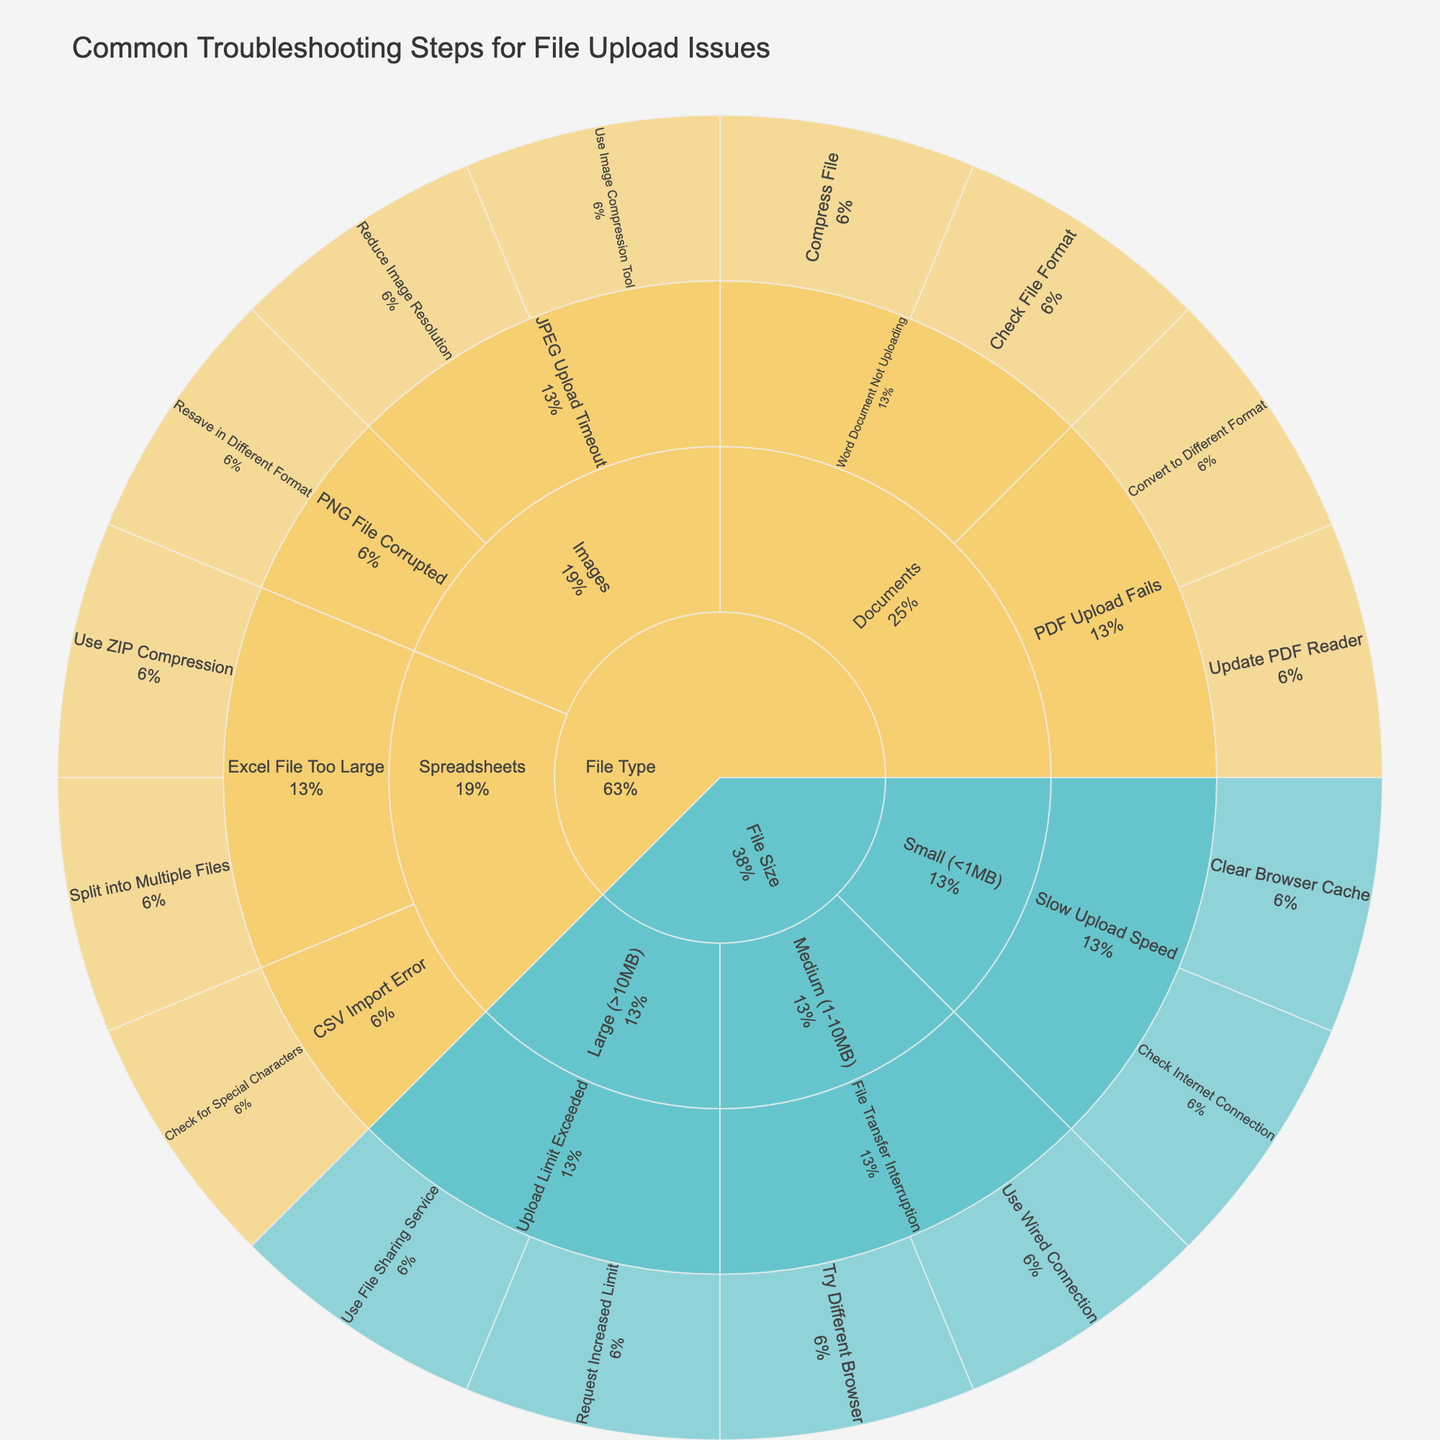What is the title of the sunburst plot? The title of the figure is typically located at the top. It gives a high-level understanding of what the plot represents.
Answer: Common Troubleshooting Steps for File Upload Issues Which category has the most subcategories? By examining the outer rings of the sunburst plot, we can identify the category with the most diverse subcategories.
Answer: File Type What are the common issues related to Word Document uploads under the File Type category? First, locate the 'File Type' category, then navigate to the 'Documents' subcategory. Identify the issues listed under 'Word Document Not Uploading'.
Answer: Check File Format, Compress File Compare the number of solutions for 'Excel File Too Large' and 'PDF Upload Fails'. Which issue has more solutions? Locate both 'Excel File Too Large' and 'PDF Upload Fails' issues within the sunburst plot and count their respective solutions.
Answer: PDF Upload Fails Which solutions are suggested for slow upload speed for files smaller than 1MB? Navigate to the 'File Size' category and the subcategory of 'Small (<1MB)', then find the related issue of 'Slow Upload Speed' and list its solutions.
Answer: Check Internet Connection, Clear Browser Cache For which file size is "Check Internet Connection" a suggested solution? Locate the specific solution 'Check Internet Connection' within the sunburst plot and identify the file size category it belongs to.
Answer: Small (<1MB) Which file type has an issue of 'JPEG Upload Timeout' and what solutions are provided for it? Find 'File Type' category and then navigate to the 'Images' subcategory to locate 'JPEG Upload Timeout' and note its solutions.
Answer: Reduce Image Resolution, Use Image Compression Tool How many solutions are there under the 'File Size' category? Examine the 'File Size' category and count all the distinct solutions listed under its respective subcategories.
Answer: 6 What are the solutions related to 'File Transfer Interruption' for medium-sized files? Identify the 'File Size' category and 'Medium (1-10MB)' subcategory and locate the issue of 'File Transfer Interruption', then list the solutions.
Answer: Use Wired Connection, Try Different Browser 